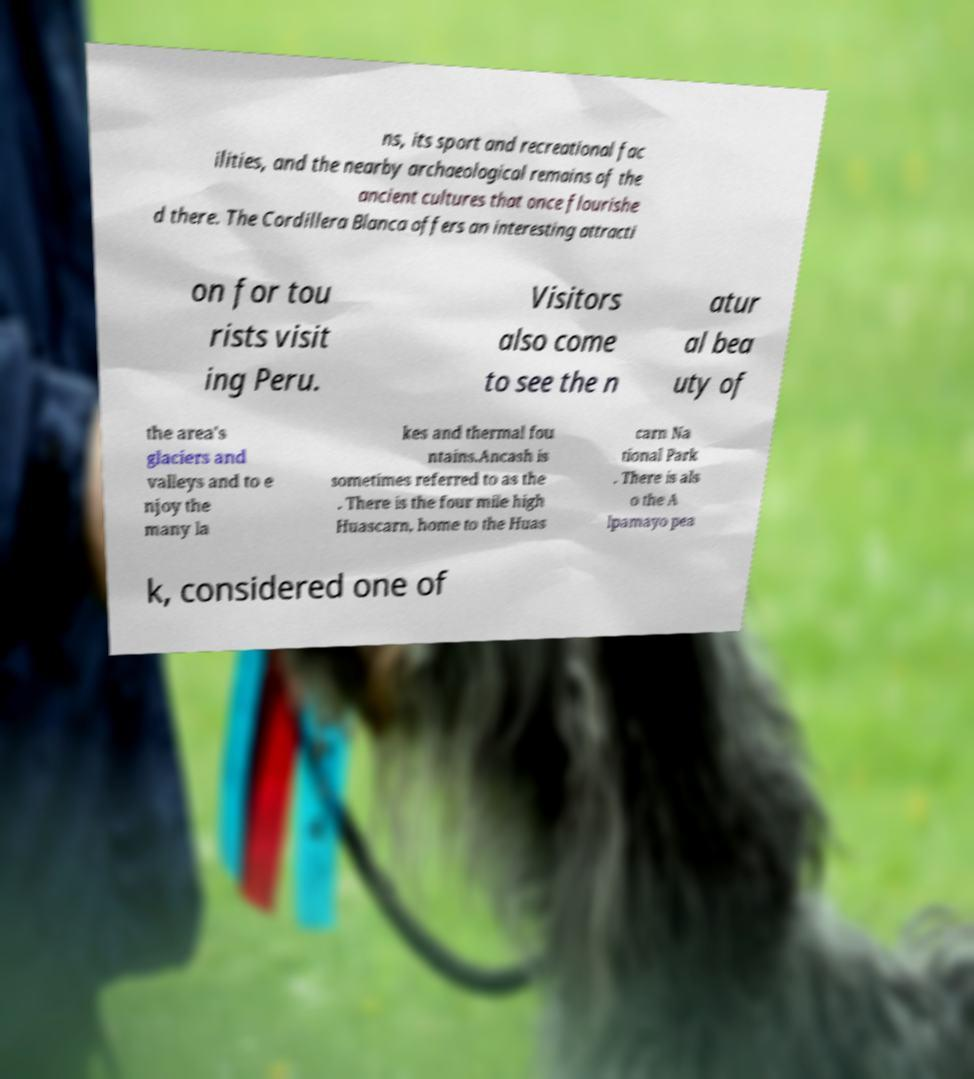Can you accurately transcribe the text from the provided image for me? ns, its sport and recreational fac ilities, and the nearby archaeological remains of the ancient cultures that once flourishe d there. The Cordillera Blanca offers an interesting attracti on for tou rists visit ing Peru. Visitors also come to see the n atur al bea uty of the area's glaciers and valleys and to e njoy the many la kes and thermal fou ntains.Ancash is sometimes referred to as the . There is the four mile high Huascarn, home to the Huas carn Na tional Park . There is als o the A lpamayo pea k, considered one of 